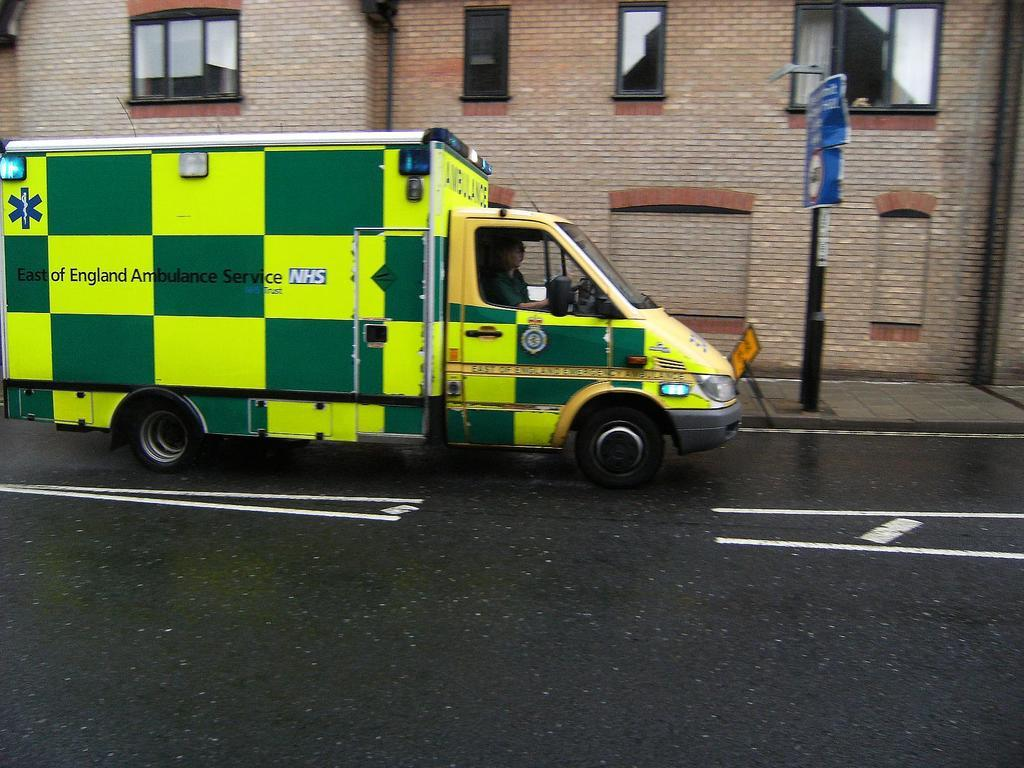How many people are in the vehicle in the image? A: There are two persons riding in the vehicle. Where is the vehicle located in the image? The vehicle is on the road. What can be seen on the right side of the image? There are signboard poles on the footpath on the right side. What type of structures are visible in the image? There are buildings visible in the image. What feature of the buildings can be seen in the image? There are windows visible in the image. What type of apple is being sung about in the song playing in the vehicle? There is no information about a song or an apple in the image, so this question cannot be answered definitively. 